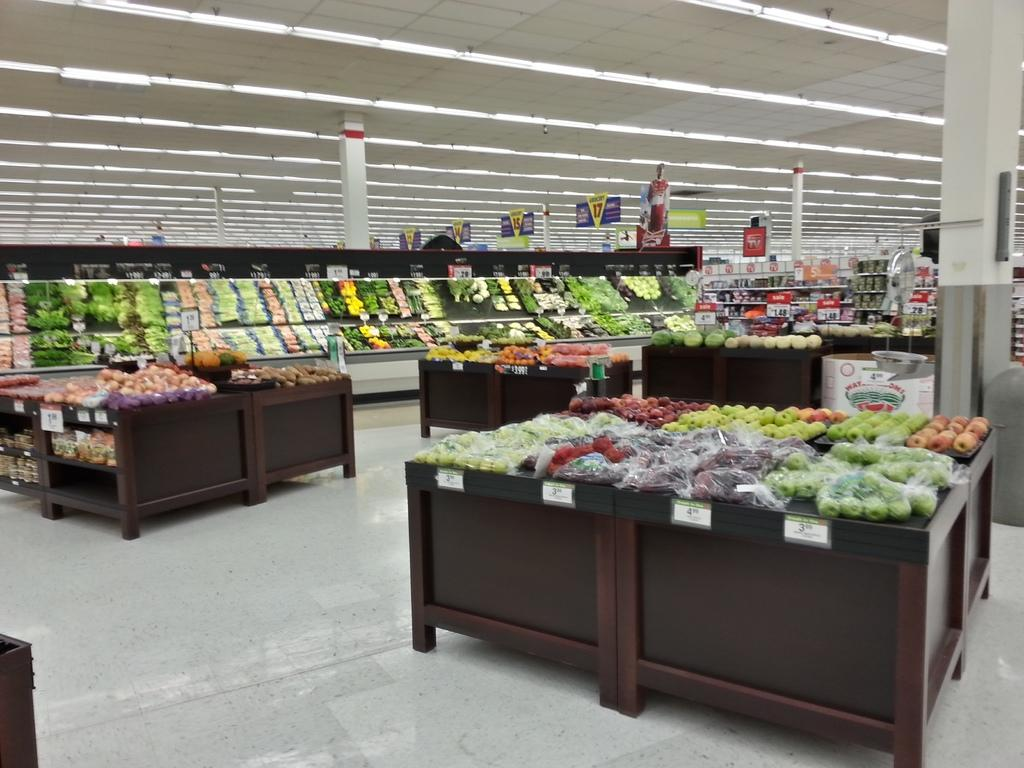What type of store is depicted in the image? There is a vegetables and fruits store in the image. How are the vegetables and fruits arranged in the store? The vegetables and fruits are kept on shelves and a table in the store. What can be seen on the floor in the image? There is a floor visible in the image. What architectural feature is present in the store? There is a pillar in the image. What type of signage is present in the store? There is a poster in the image. What provides illumination in the store? There are lights visible in the image. How many forks are placed on the table with the vegetables and fruits? There is no fork present on the table with the vegetables and fruits in the image. What type of fingerprint can be seen on the poster in the image? There is no fingerprint visible on the poster in the image. 